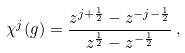<formula> <loc_0><loc_0><loc_500><loc_500>\chi ^ { j } ( g ) = \frac { z ^ { j + \frac { 1 } { 2 } } - z ^ { - j - \frac { 1 } { 2 } } } { z ^ { \frac { 1 } { 2 } } - z ^ { - \frac { 1 } { 2 } } } \, ,</formula> 